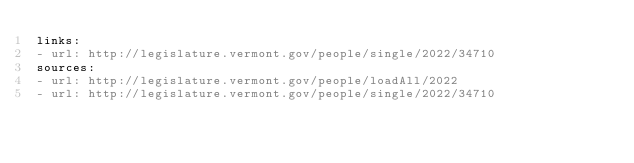<code> <loc_0><loc_0><loc_500><loc_500><_YAML_>links:
- url: http://legislature.vermont.gov/people/single/2022/34710
sources:
- url: http://legislature.vermont.gov/people/loadAll/2022
- url: http://legislature.vermont.gov/people/single/2022/34710
</code> 